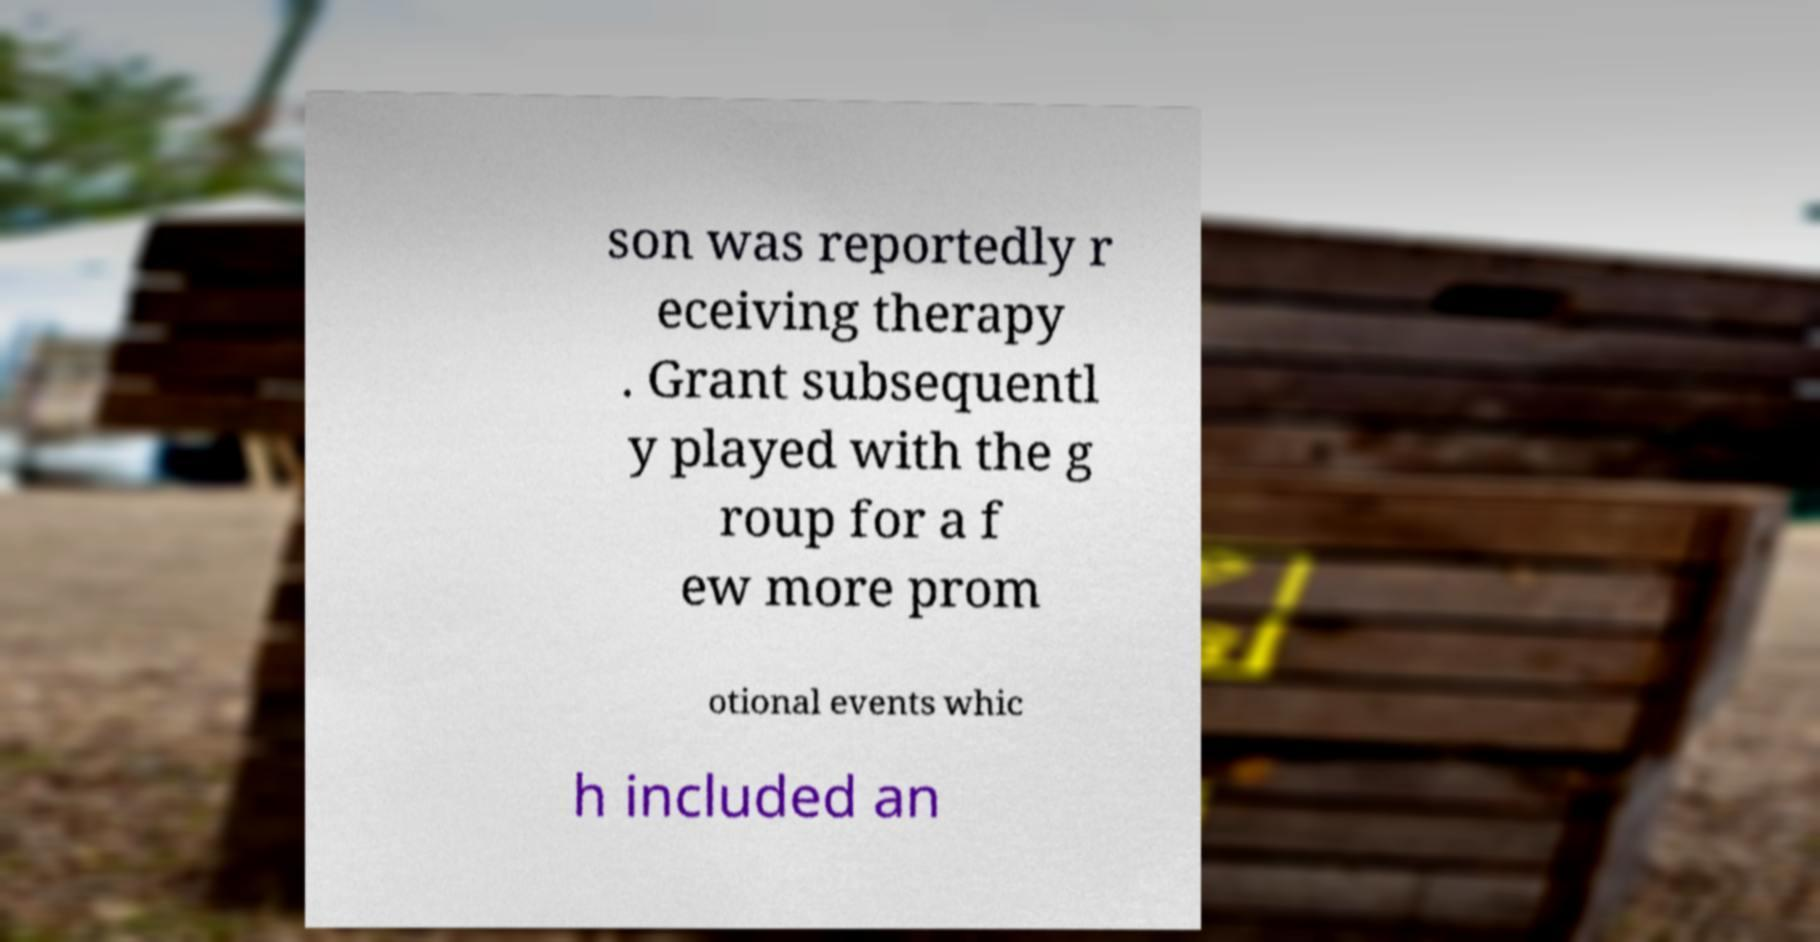Please read and relay the text visible in this image. What does it say? son was reportedly r eceiving therapy . Grant subsequentl y played with the g roup for a f ew more prom otional events whic h included an 